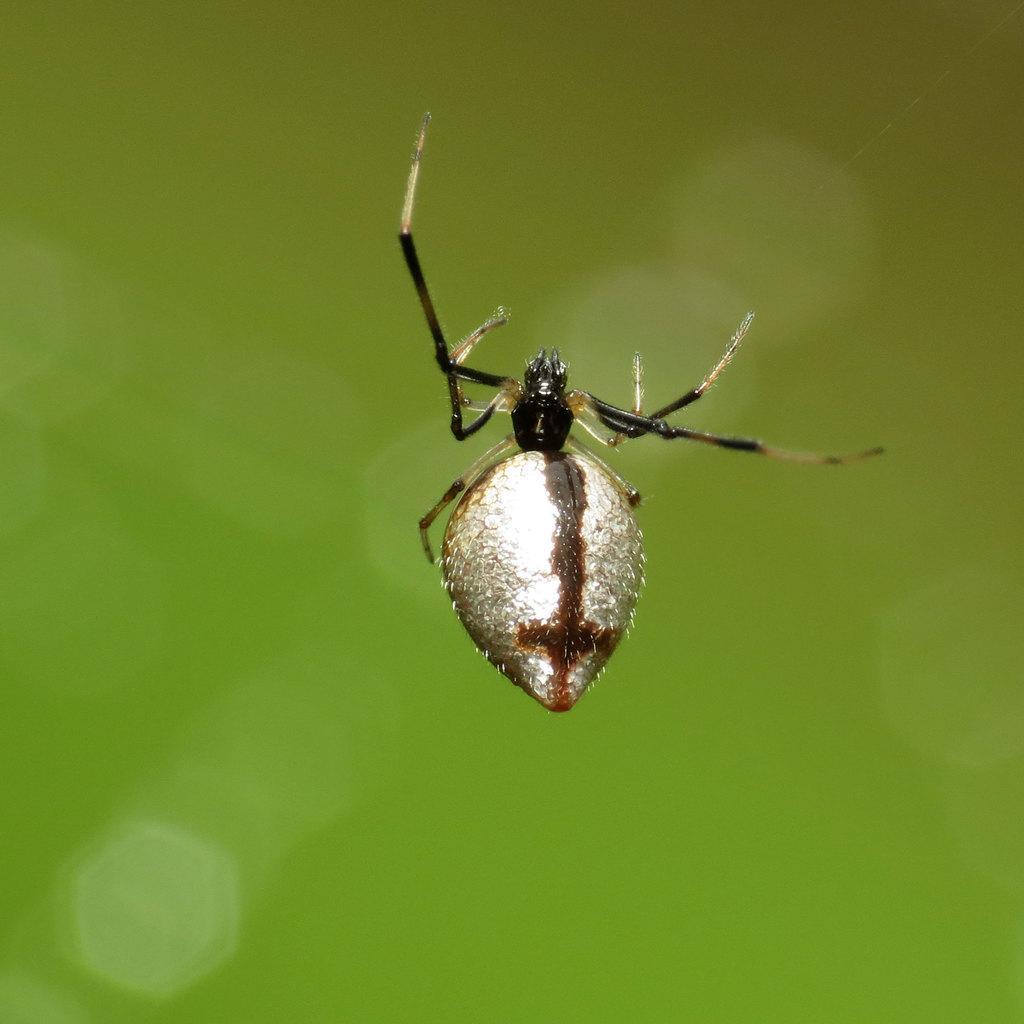Describe this image in one or two sentences. Background portion of the picture is blur and green in color. In this picture we can see an insect. 